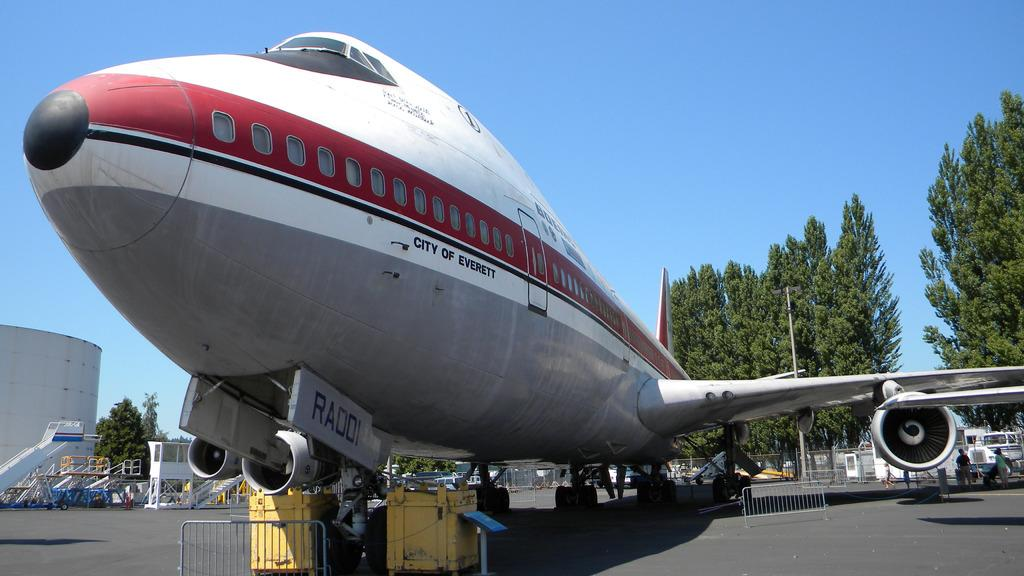<image>
Share a concise interpretation of the image provided. a parked plane with the words City of Evertt on it 